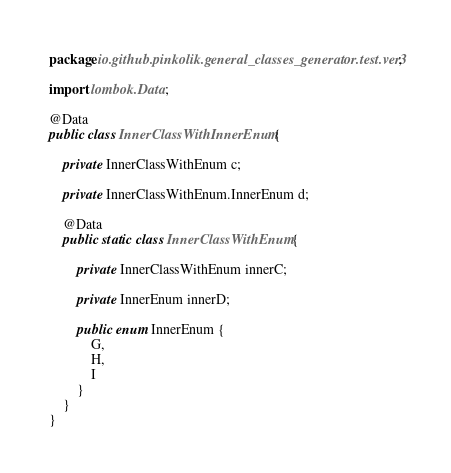Convert code to text. <code><loc_0><loc_0><loc_500><loc_500><_Java_>package io.github.pinkolik.general_classes_generator.test.ver3;

import lombok.Data;

@Data
public class InnerClassWithInnerEnum {

    private InnerClassWithEnum c;

    private InnerClassWithEnum.InnerEnum d;

    @Data
    public static class InnerClassWithEnum {

        private InnerClassWithEnum innerC;

        private InnerEnum innerD;

        public enum InnerEnum {
            G,
            H,
            I
        }
    }
}
</code> 